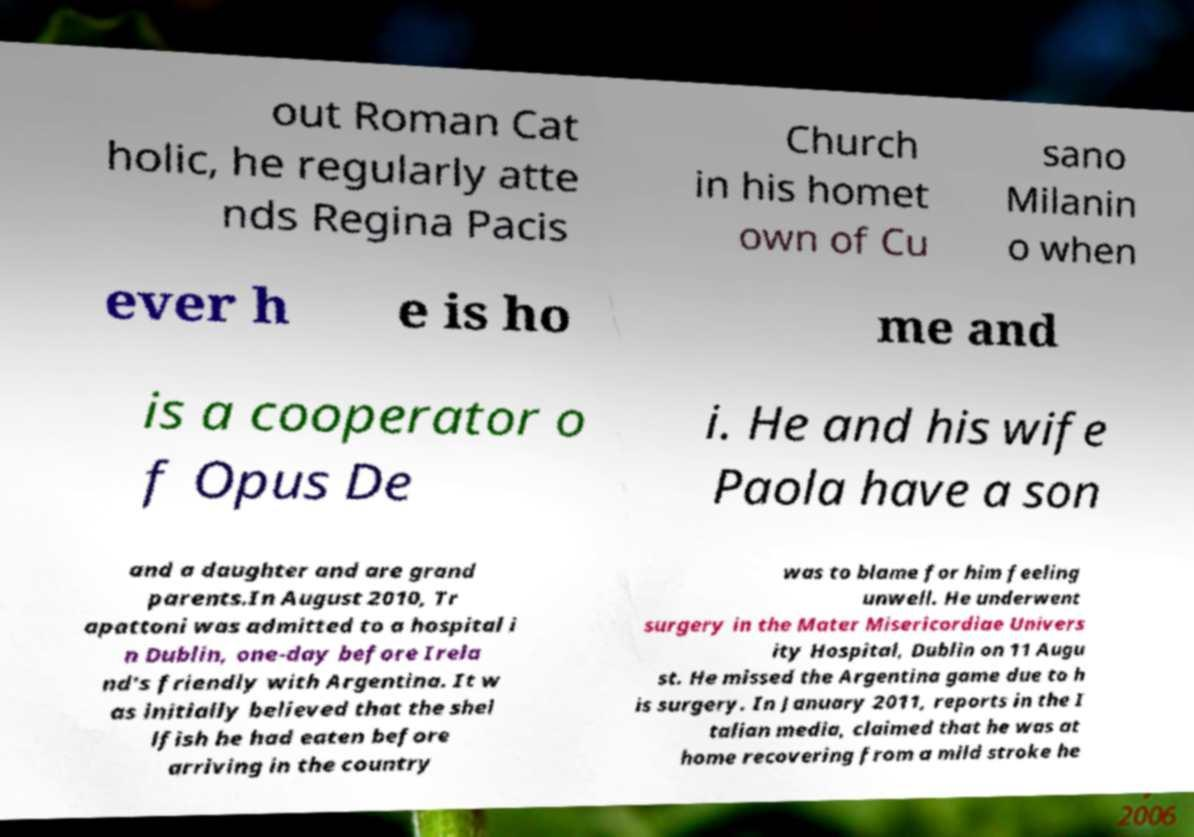Could you assist in decoding the text presented in this image and type it out clearly? out Roman Cat holic, he regularly atte nds Regina Pacis Church in his homet own of Cu sano Milanin o when ever h e is ho me and is a cooperator o f Opus De i. He and his wife Paola have a son and a daughter and are grand parents.In August 2010, Tr apattoni was admitted to a hospital i n Dublin, one-day before Irela nd's friendly with Argentina. It w as initially believed that the shel lfish he had eaten before arriving in the country was to blame for him feeling unwell. He underwent surgery in the Mater Misericordiae Univers ity Hospital, Dublin on 11 Augu st. He missed the Argentina game due to h is surgery. In January 2011, reports in the I talian media, claimed that he was at home recovering from a mild stroke he 